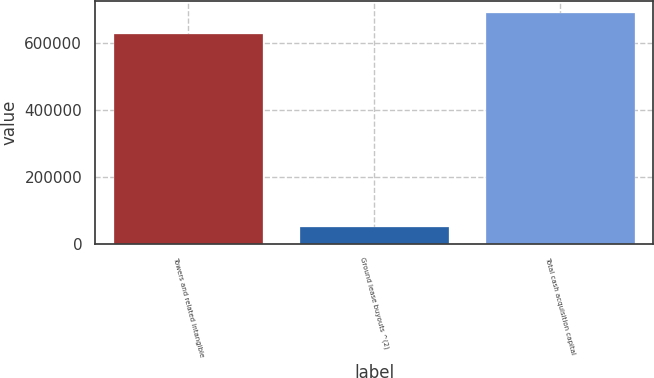Convert chart to OTSL. <chart><loc_0><loc_0><loc_500><loc_500><bar_chart><fcel>Towers and related intangible<fcel>Ground lease buyouts ^(2)<fcel>Total cash acquisition capital<nl><fcel>628423<fcel>48956<fcel>691265<nl></chart> 